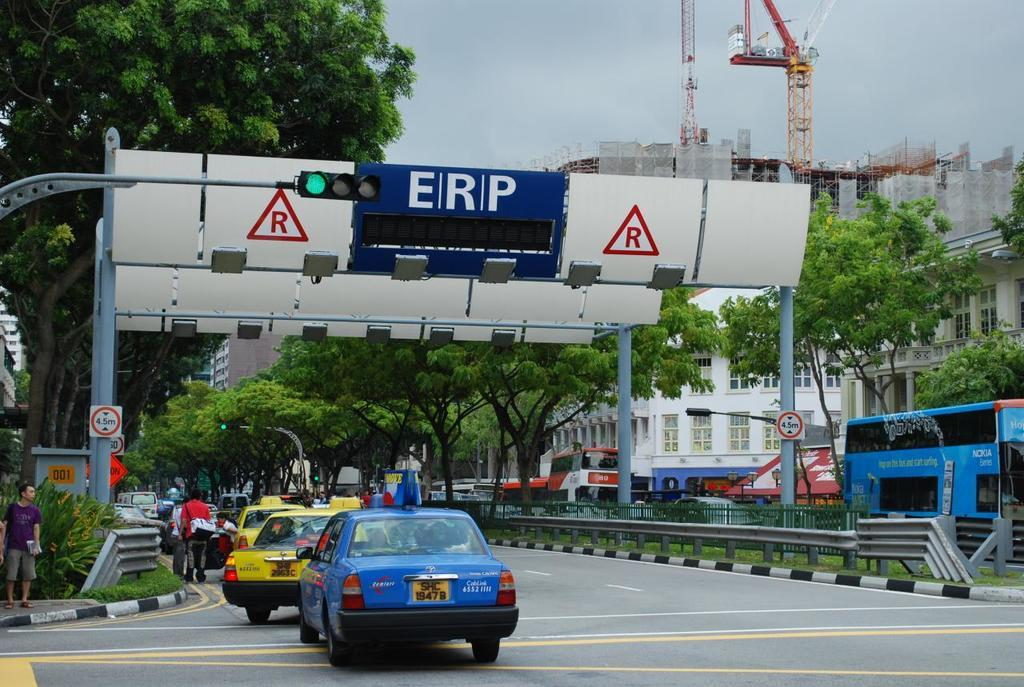<image>
Create a compact narrative representing the image presented. A line of cars move under a sign that says "ERP." 